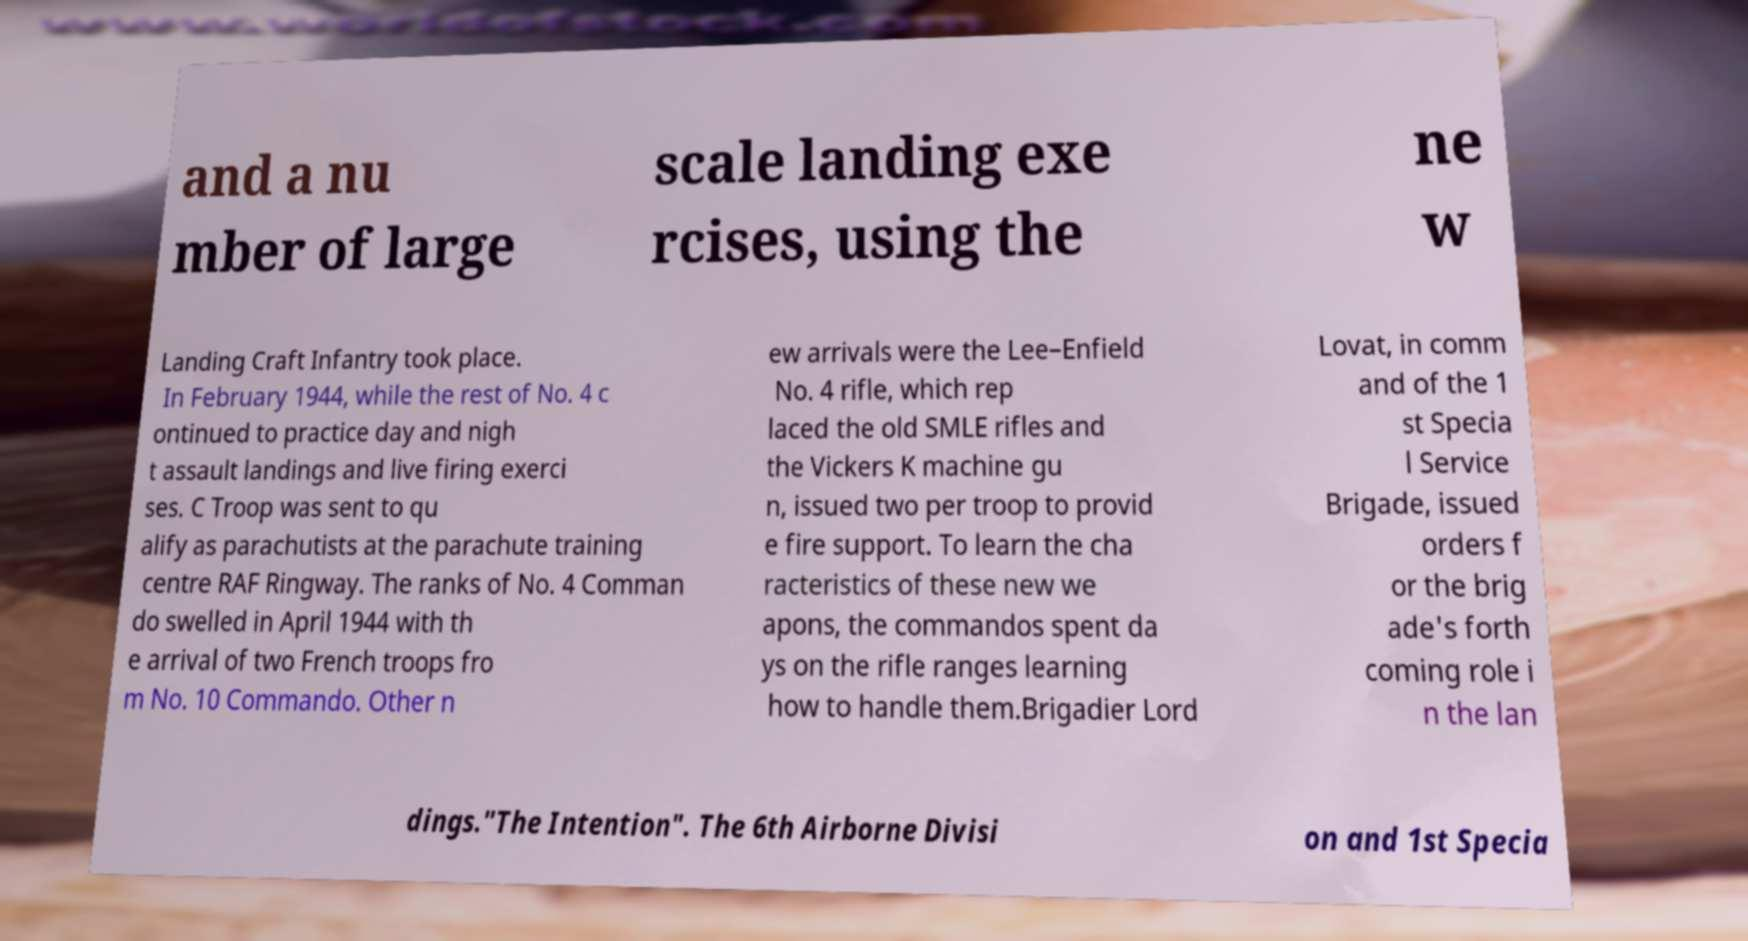Could you extract and type out the text from this image? and a nu mber of large scale landing exe rcises, using the ne w Landing Craft Infantry took place. In February 1944, while the rest of No. 4 c ontinued to practice day and nigh t assault landings and live firing exerci ses. C Troop was sent to qu alify as parachutists at the parachute training centre RAF Ringway. The ranks of No. 4 Comman do swelled in April 1944 with th e arrival of two French troops fro m No. 10 Commando. Other n ew arrivals were the Lee–Enfield No. 4 rifle, which rep laced the old SMLE rifles and the Vickers K machine gu n, issued two per troop to provid e fire support. To learn the cha racteristics of these new we apons, the commandos spent da ys on the rifle ranges learning how to handle them.Brigadier Lord Lovat, in comm and of the 1 st Specia l Service Brigade, issued orders f or the brig ade's forth coming role i n the lan dings."The Intention". The 6th Airborne Divisi on and 1st Specia 